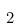<formula> <loc_0><loc_0><loc_500><loc_500>2</formula> 